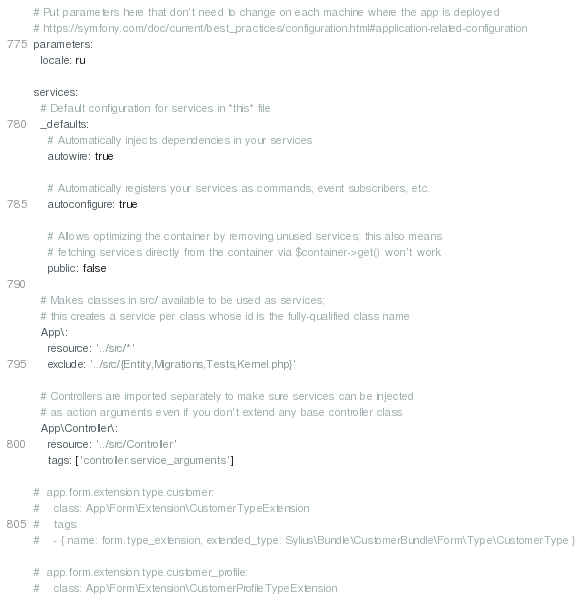<code> <loc_0><loc_0><loc_500><loc_500><_YAML_># Put parameters here that don't need to change on each machine where the app is deployed
# https://symfony.com/doc/current/best_practices/configuration.html#application-related-configuration
parameters:
  locale: ru

services:
  # Default configuration for services in *this* file
  _defaults:
    # Automatically injects dependencies in your services
    autowire: true

    # Automatically registers your services as commands, event subscribers, etc.
    autoconfigure: true

    # Allows optimizing the container by removing unused services; this also means
    # fetching services directly from the container via $container->get() won't work
    public: false

  # Makes classes in src/ available to be used as services;
  # this creates a service per class whose id is the fully-qualified class name
  App\:
    resource: '../src/*'
    exclude: '../src/{Entity,Migrations,Tests,Kernel.php}'

  # Controllers are imported separately to make sure services can be injected
  # as action arguments even if you don't extend any base controller class
  App\Controller\:
    resource: '../src/Controller'
    tags: ['controller.service_arguments']

#  app.form.extension.type.customer:
#    class: App\Form\Extension\CustomerTypeExtension
#    tags:
#    - { name: form.type_extension, extended_type: Sylius\Bundle\CustomerBundle\Form\Type\CustomerType }

#  app.form.extension.type.customer_profile:
#    class: App\Form\Extension\CustomerProfileTypeExtension</code> 